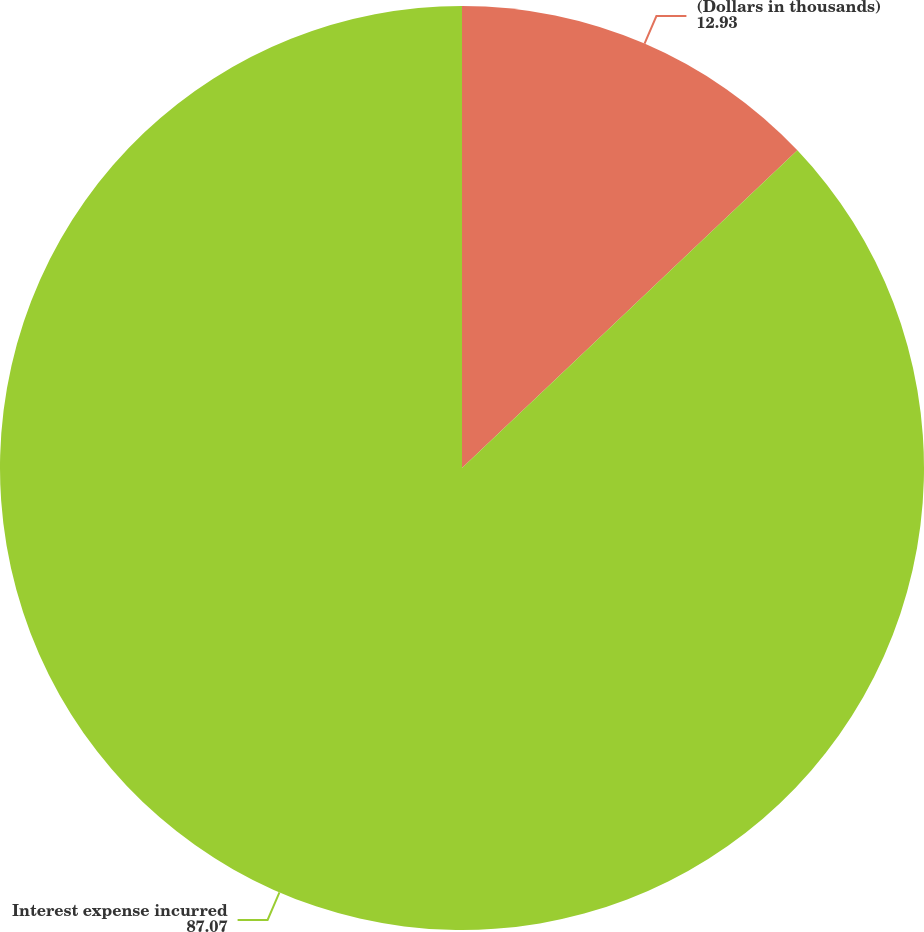<chart> <loc_0><loc_0><loc_500><loc_500><pie_chart><fcel>(Dollars in thousands)<fcel>Interest expense incurred<nl><fcel>12.93%<fcel>87.07%<nl></chart> 